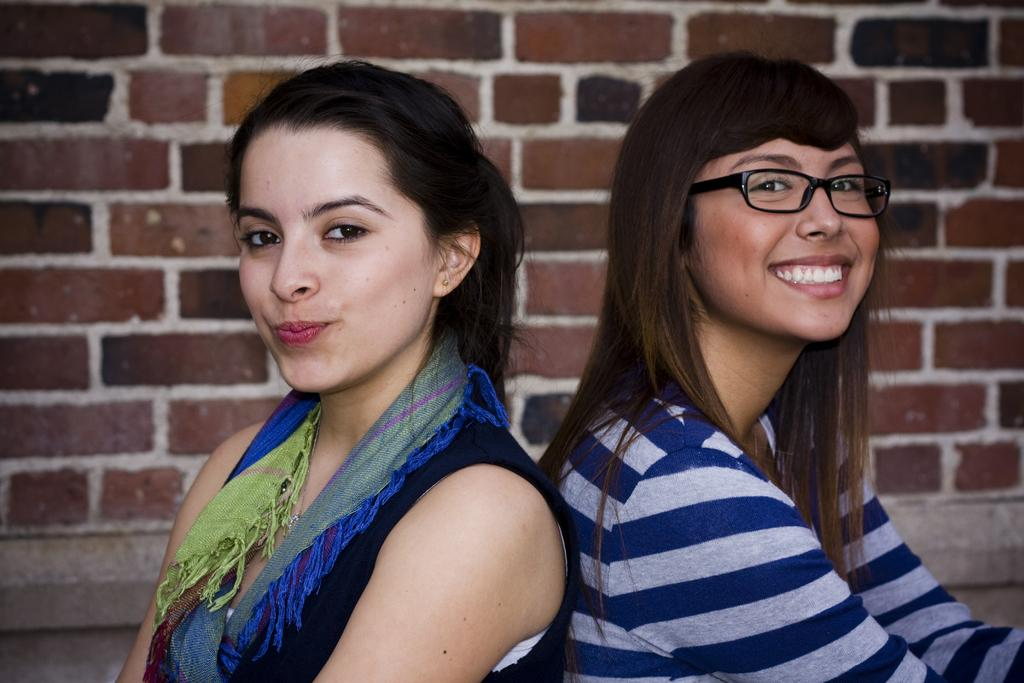How many people are in the image? There are two people in the image. What expressions do the people have on their faces? The people are wearing smiles on their faces. What can be seen in the background of the image? There is a wall visible in the background of the image. What type of mouth is visible on the wall in the image? There is no mouth visible on the wall in the image. Can you see an airport in the background of the image? No, there is no airport visible in the image; only a wall is present in the background. 